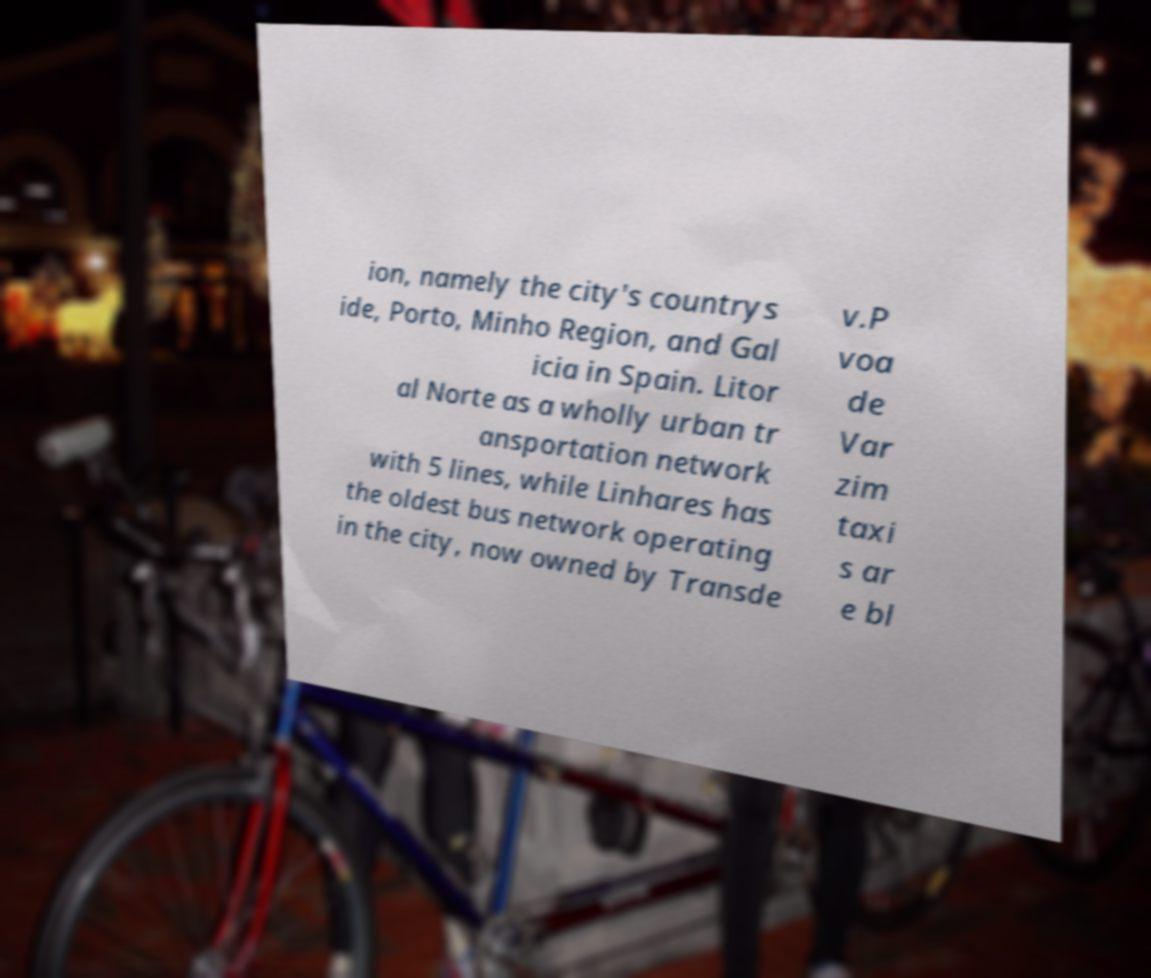Can you read and provide the text displayed in the image?This photo seems to have some interesting text. Can you extract and type it out for me? ion, namely the city's countrys ide, Porto, Minho Region, and Gal icia in Spain. Litor al Norte as a wholly urban tr ansportation network with 5 lines, while Linhares has the oldest bus network operating in the city, now owned by Transde v.P voa de Var zim taxi s ar e bl 